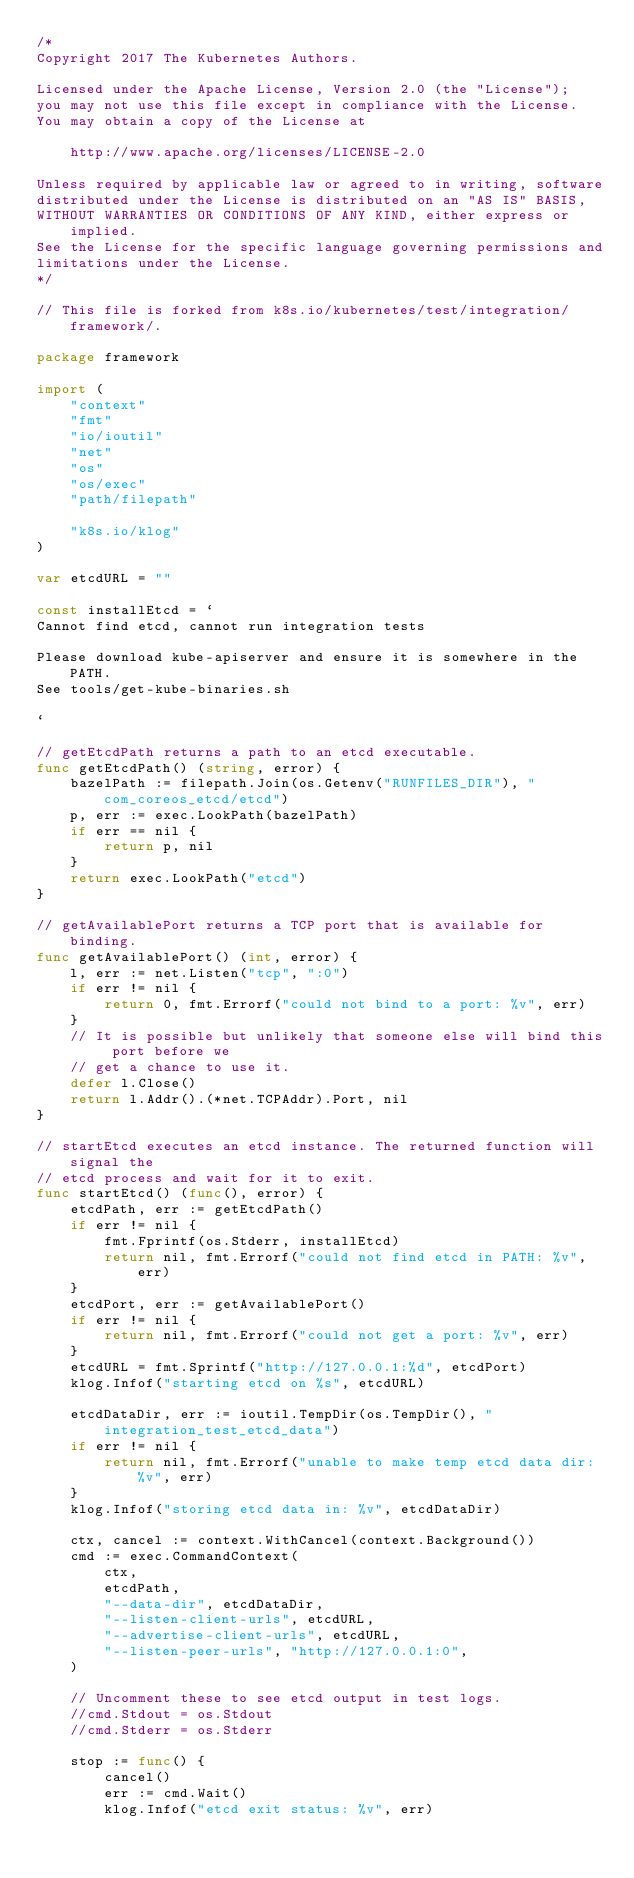Convert code to text. <code><loc_0><loc_0><loc_500><loc_500><_Go_>/*
Copyright 2017 The Kubernetes Authors.

Licensed under the Apache License, Version 2.0 (the "License");
you may not use this file except in compliance with the License.
You may obtain a copy of the License at

    http://www.apache.org/licenses/LICENSE-2.0

Unless required by applicable law or agreed to in writing, software
distributed under the License is distributed on an "AS IS" BASIS,
WITHOUT WARRANTIES OR CONDITIONS OF ANY KIND, either express or implied.
See the License for the specific language governing permissions and
limitations under the License.
*/

// This file is forked from k8s.io/kubernetes/test/integration/framework/.

package framework

import (
	"context"
	"fmt"
	"io/ioutil"
	"net"
	"os"
	"os/exec"
	"path/filepath"

	"k8s.io/klog"
)

var etcdURL = ""

const installEtcd = `
Cannot find etcd, cannot run integration tests

Please download kube-apiserver and ensure it is somewhere in the PATH.
See tools/get-kube-binaries.sh

`

// getEtcdPath returns a path to an etcd executable.
func getEtcdPath() (string, error) {
	bazelPath := filepath.Join(os.Getenv("RUNFILES_DIR"), "com_coreos_etcd/etcd")
	p, err := exec.LookPath(bazelPath)
	if err == nil {
		return p, nil
	}
	return exec.LookPath("etcd")
}

// getAvailablePort returns a TCP port that is available for binding.
func getAvailablePort() (int, error) {
	l, err := net.Listen("tcp", ":0")
	if err != nil {
		return 0, fmt.Errorf("could not bind to a port: %v", err)
	}
	// It is possible but unlikely that someone else will bind this port before we
	// get a chance to use it.
	defer l.Close()
	return l.Addr().(*net.TCPAddr).Port, nil
}

// startEtcd executes an etcd instance. The returned function will signal the
// etcd process and wait for it to exit.
func startEtcd() (func(), error) {
	etcdPath, err := getEtcdPath()
	if err != nil {
		fmt.Fprintf(os.Stderr, installEtcd)
		return nil, fmt.Errorf("could not find etcd in PATH: %v", err)
	}
	etcdPort, err := getAvailablePort()
	if err != nil {
		return nil, fmt.Errorf("could not get a port: %v", err)
	}
	etcdURL = fmt.Sprintf("http://127.0.0.1:%d", etcdPort)
	klog.Infof("starting etcd on %s", etcdURL)

	etcdDataDir, err := ioutil.TempDir(os.TempDir(), "integration_test_etcd_data")
	if err != nil {
		return nil, fmt.Errorf("unable to make temp etcd data dir: %v", err)
	}
	klog.Infof("storing etcd data in: %v", etcdDataDir)

	ctx, cancel := context.WithCancel(context.Background())
	cmd := exec.CommandContext(
		ctx,
		etcdPath,
		"--data-dir", etcdDataDir,
		"--listen-client-urls", etcdURL,
		"--advertise-client-urls", etcdURL,
		"--listen-peer-urls", "http://127.0.0.1:0",
	)

	// Uncomment these to see etcd output in test logs.
	//cmd.Stdout = os.Stdout
	//cmd.Stderr = os.Stderr

	stop := func() {
		cancel()
		err := cmd.Wait()
		klog.Infof("etcd exit status: %v", err)</code> 